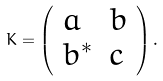<formula> <loc_0><loc_0><loc_500><loc_500>K = \left ( \begin{array} { l l } a & b \\ b ^ { * } & c \end{array} \right ) .</formula> 